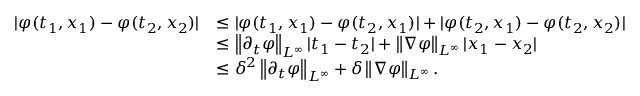<formula> <loc_0><loc_0><loc_500><loc_500>\begin{array} { r l } { | \varphi ( t _ { 1 } , x _ { 1 } ) - \varphi ( t _ { 2 } , x _ { 2 } ) | } & { \leq | \varphi ( t _ { 1 } , x _ { 1 } ) - \varphi ( t _ { 2 } , x _ { 1 } ) | + | \varphi ( t _ { 2 } , x _ { 1 } ) - \varphi ( t _ { 2 } , x _ { 2 } ) | } \\ & { \leq \left \| \partial _ { t } \varphi \right \| _ { L ^ { \infty } } | t _ { 1 } - t _ { 2 } | + \left \| \nabla \varphi \right \| _ { L ^ { \infty } } | x _ { 1 } - x _ { 2 } | } \\ & { \leq \delta ^ { 2 } \left \| \partial _ { t } \varphi \right \| _ { L ^ { \infty } } + \delta \left \| \nabla \varphi \right \| _ { L ^ { \infty } } . } \end{array}</formula> 